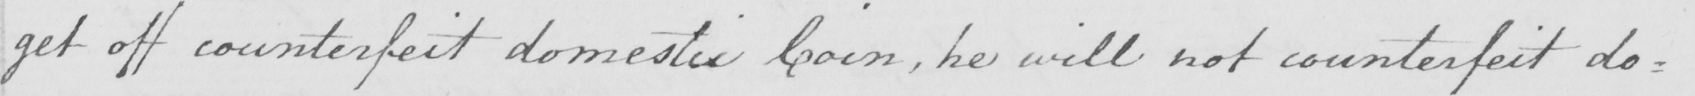Please transcribe the handwritten text in this image. get off counterfeit domestic Coin , he will not counterfeit do= 